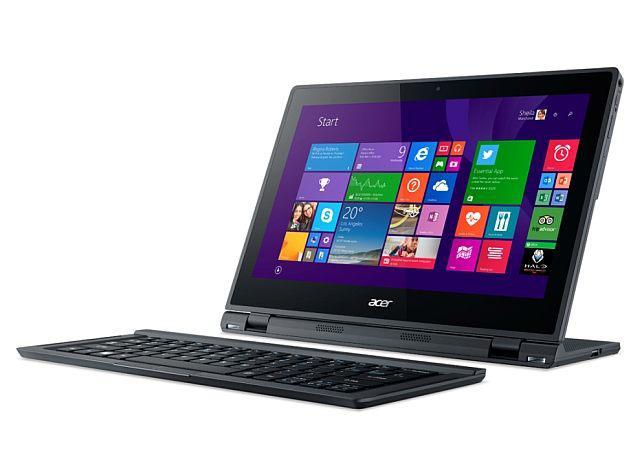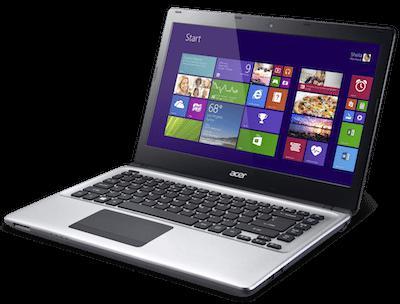The first image is the image on the left, the second image is the image on the right. Given the left and right images, does the statement "The laptops face the same direction." hold true? Answer yes or no. Yes. 